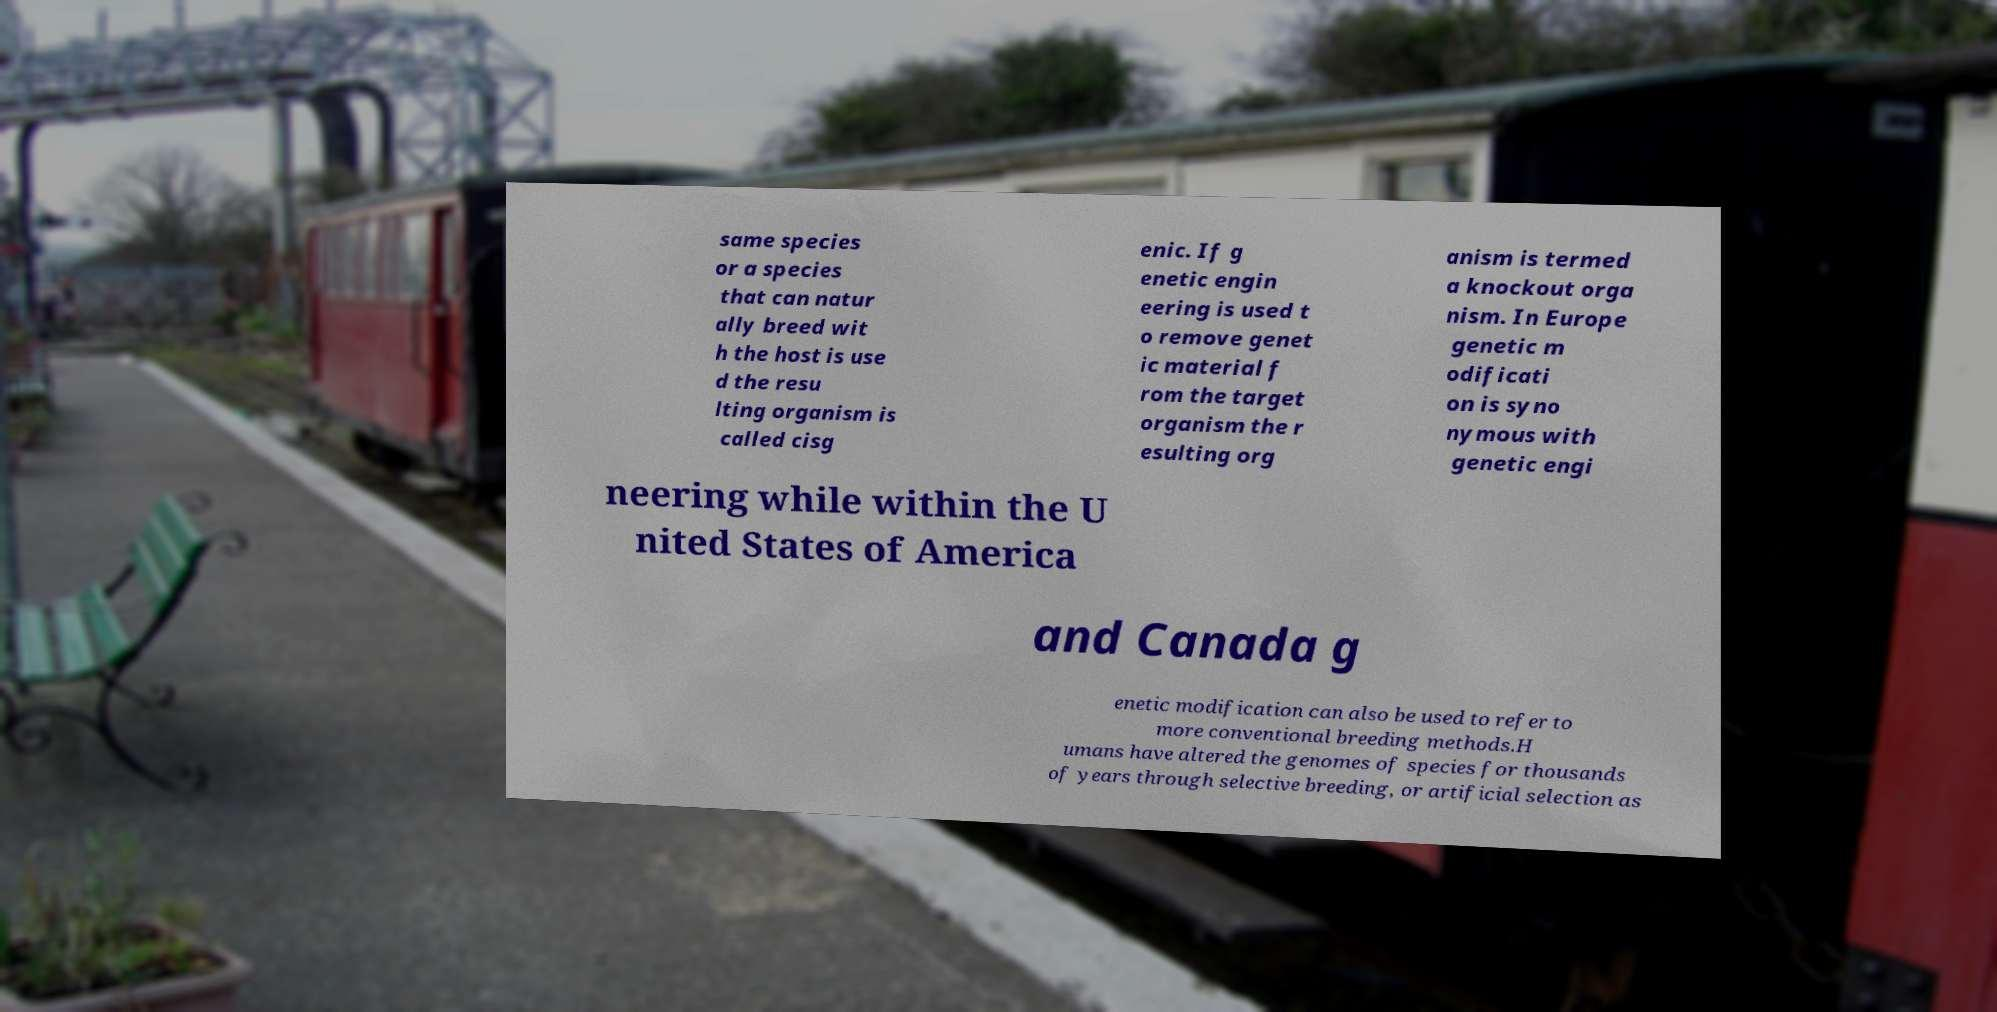There's text embedded in this image that I need extracted. Can you transcribe it verbatim? same species or a species that can natur ally breed wit h the host is use d the resu lting organism is called cisg enic. If g enetic engin eering is used t o remove genet ic material f rom the target organism the r esulting org anism is termed a knockout orga nism. In Europe genetic m odificati on is syno nymous with genetic engi neering while within the U nited States of America and Canada g enetic modification can also be used to refer to more conventional breeding methods.H umans have altered the genomes of species for thousands of years through selective breeding, or artificial selection as 